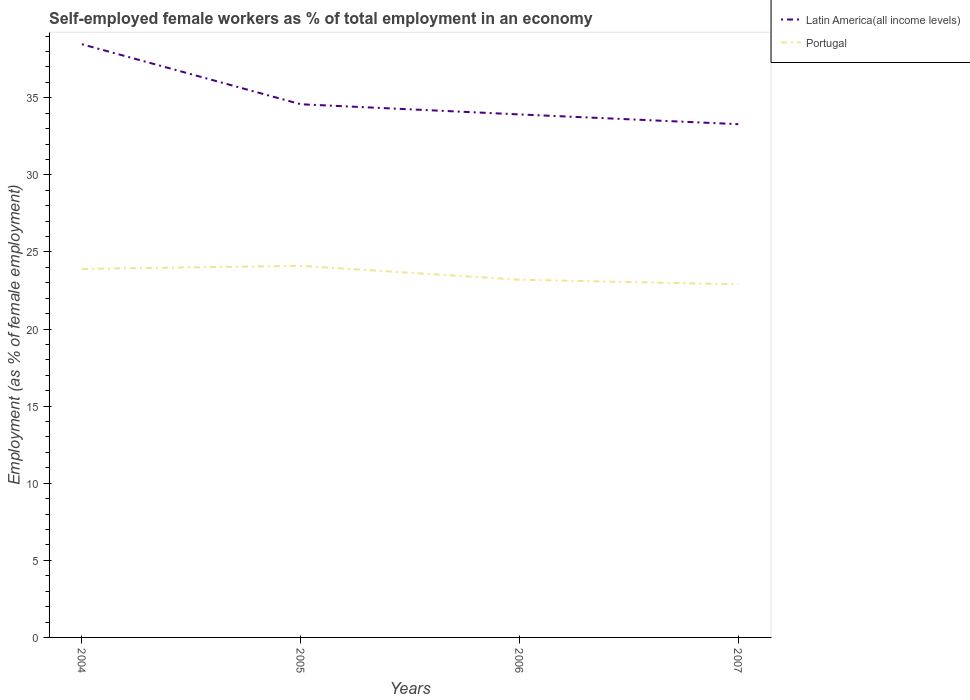How many different coloured lines are there?
Provide a short and direct response. 2. Is the number of lines equal to the number of legend labels?
Your answer should be compact. Yes. Across all years, what is the maximum percentage of self-employed female workers in Latin America(all income levels)?
Your answer should be very brief. 33.29. What is the total percentage of self-employed female workers in Portugal in the graph?
Ensure brevity in your answer.  0.3. What is the difference between the highest and the second highest percentage of self-employed female workers in Portugal?
Offer a very short reply. 1.2. Is the percentage of self-employed female workers in Portugal strictly greater than the percentage of self-employed female workers in Latin America(all income levels) over the years?
Offer a terse response. Yes. What is the difference between two consecutive major ticks on the Y-axis?
Offer a very short reply. 5. Does the graph contain any zero values?
Your answer should be very brief. No. Does the graph contain grids?
Ensure brevity in your answer.  No. What is the title of the graph?
Ensure brevity in your answer.  Self-employed female workers as % of total employment in an economy. Does "China" appear as one of the legend labels in the graph?
Provide a short and direct response. No. What is the label or title of the X-axis?
Offer a terse response. Years. What is the label or title of the Y-axis?
Offer a very short reply. Employment (as % of female employment). What is the Employment (as % of female employment) of Latin America(all income levels) in 2004?
Provide a succinct answer. 38.47. What is the Employment (as % of female employment) of Portugal in 2004?
Your answer should be compact. 23.9. What is the Employment (as % of female employment) of Latin America(all income levels) in 2005?
Keep it short and to the point. 34.58. What is the Employment (as % of female employment) in Portugal in 2005?
Your answer should be very brief. 24.1. What is the Employment (as % of female employment) of Latin America(all income levels) in 2006?
Provide a succinct answer. 33.92. What is the Employment (as % of female employment) of Portugal in 2006?
Keep it short and to the point. 23.2. What is the Employment (as % of female employment) in Latin America(all income levels) in 2007?
Provide a short and direct response. 33.29. What is the Employment (as % of female employment) in Portugal in 2007?
Make the answer very short. 22.9. Across all years, what is the maximum Employment (as % of female employment) of Latin America(all income levels)?
Your answer should be compact. 38.47. Across all years, what is the maximum Employment (as % of female employment) of Portugal?
Offer a terse response. 24.1. Across all years, what is the minimum Employment (as % of female employment) of Latin America(all income levels)?
Your answer should be compact. 33.29. Across all years, what is the minimum Employment (as % of female employment) in Portugal?
Your response must be concise. 22.9. What is the total Employment (as % of female employment) of Latin America(all income levels) in the graph?
Provide a succinct answer. 140.25. What is the total Employment (as % of female employment) in Portugal in the graph?
Give a very brief answer. 94.1. What is the difference between the Employment (as % of female employment) in Latin America(all income levels) in 2004 and that in 2005?
Offer a terse response. 3.89. What is the difference between the Employment (as % of female employment) of Latin America(all income levels) in 2004 and that in 2006?
Give a very brief answer. 4.55. What is the difference between the Employment (as % of female employment) of Latin America(all income levels) in 2004 and that in 2007?
Your response must be concise. 5.18. What is the difference between the Employment (as % of female employment) in Portugal in 2004 and that in 2007?
Your answer should be very brief. 1. What is the difference between the Employment (as % of female employment) of Latin America(all income levels) in 2005 and that in 2006?
Offer a terse response. 0.66. What is the difference between the Employment (as % of female employment) in Portugal in 2005 and that in 2006?
Make the answer very short. 0.9. What is the difference between the Employment (as % of female employment) of Latin America(all income levels) in 2005 and that in 2007?
Provide a succinct answer. 1.29. What is the difference between the Employment (as % of female employment) in Latin America(all income levels) in 2006 and that in 2007?
Your response must be concise. 0.63. What is the difference between the Employment (as % of female employment) of Latin America(all income levels) in 2004 and the Employment (as % of female employment) of Portugal in 2005?
Provide a succinct answer. 14.37. What is the difference between the Employment (as % of female employment) of Latin America(all income levels) in 2004 and the Employment (as % of female employment) of Portugal in 2006?
Offer a very short reply. 15.27. What is the difference between the Employment (as % of female employment) of Latin America(all income levels) in 2004 and the Employment (as % of female employment) of Portugal in 2007?
Provide a succinct answer. 15.57. What is the difference between the Employment (as % of female employment) in Latin America(all income levels) in 2005 and the Employment (as % of female employment) in Portugal in 2006?
Make the answer very short. 11.38. What is the difference between the Employment (as % of female employment) of Latin America(all income levels) in 2005 and the Employment (as % of female employment) of Portugal in 2007?
Your answer should be compact. 11.68. What is the difference between the Employment (as % of female employment) in Latin America(all income levels) in 2006 and the Employment (as % of female employment) in Portugal in 2007?
Provide a short and direct response. 11.02. What is the average Employment (as % of female employment) in Latin America(all income levels) per year?
Your answer should be very brief. 35.06. What is the average Employment (as % of female employment) in Portugal per year?
Provide a succinct answer. 23.52. In the year 2004, what is the difference between the Employment (as % of female employment) of Latin America(all income levels) and Employment (as % of female employment) of Portugal?
Your answer should be compact. 14.57. In the year 2005, what is the difference between the Employment (as % of female employment) in Latin America(all income levels) and Employment (as % of female employment) in Portugal?
Your answer should be very brief. 10.48. In the year 2006, what is the difference between the Employment (as % of female employment) of Latin America(all income levels) and Employment (as % of female employment) of Portugal?
Make the answer very short. 10.72. In the year 2007, what is the difference between the Employment (as % of female employment) in Latin America(all income levels) and Employment (as % of female employment) in Portugal?
Your response must be concise. 10.39. What is the ratio of the Employment (as % of female employment) in Latin America(all income levels) in 2004 to that in 2005?
Offer a very short reply. 1.11. What is the ratio of the Employment (as % of female employment) in Latin America(all income levels) in 2004 to that in 2006?
Provide a short and direct response. 1.13. What is the ratio of the Employment (as % of female employment) of Portugal in 2004 to that in 2006?
Your response must be concise. 1.03. What is the ratio of the Employment (as % of female employment) of Latin America(all income levels) in 2004 to that in 2007?
Your answer should be compact. 1.16. What is the ratio of the Employment (as % of female employment) of Portugal in 2004 to that in 2007?
Provide a succinct answer. 1.04. What is the ratio of the Employment (as % of female employment) of Latin America(all income levels) in 2005 to that in 2006?
Keep it short and to the point. 1.02. What is the ratio of the Employment (as % of female employment) of Portugal in 2005 to that in 2006?
Provide a succinct answer. 1.04. What is the ratio of the Employment (as % of female employment) of Latin America(all income levels) in 2005 to that in 2007?
Ensure brevity in your answer.  1.04. What is the ratio of the Employment (as % of female employment) in Portugal in 2005 to that in 2007?
Give a very brief answer. 1.05. What is the ratio of the Employment (as % of female employment) in Portugal in 2006 to that in 2007?
Offer a terse response. 1.01. What is the difference between the highest and the second highest Employment (as % of female employment) in Latin America(all income levels)?
Your response must be concise. 3.89. What is the difference between the highest and the second highest Employment (as % of female employment) of Portugal?
Your answer should be compact. 0.2. What is the difference between the highest and the lowest Employment (as % of female employment) in Latin America(all income levels)?
Provide a succinct answer. 5.18. What is the difference between the highest and the lowest Employment (as % of female employment) in Portugal?
Your answer should be very brief. 1.2. 